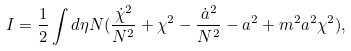Convert formula to latex. <formula><loc_0><loc_0><loc_500><loc_500>I = \frac { 1 } { 2 } \int d \eta N ( \frac { \dot { \chi } ^ { 2 } } { N ^ { 2 } } + \chi ^ { 2 } - \frac { \dot { a } ^ { 2 } } { N ^ { 2 } } - a ^ { 2 } + m ^ { 2 } a ^ { 2 } \chi ^ { 2 } ) ,</formula> 